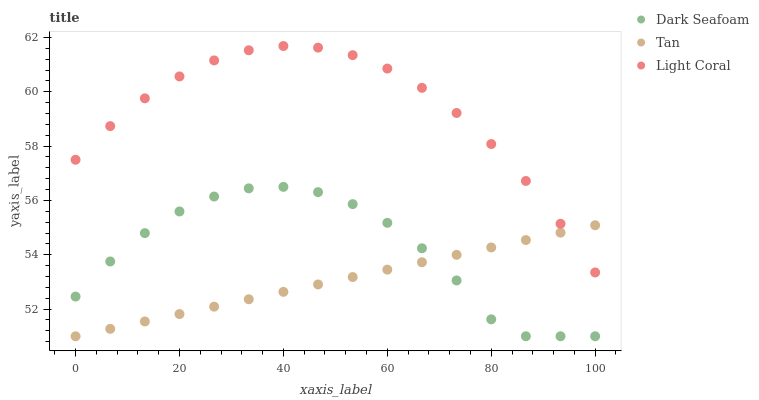Does Tan have the minimum area under the curve?
Answer yes or no. Yes. Does Light Coral have the maximum area under the curve?
Answer yes or no. Yes. Does Dark Seafoam have the minimum area under the curve?
Answer yes or no. No. Does Dark Seafoam have the maximum area under the curve?
Answer yes or no. No. Is Tan the smoothest?
Answer yes or no. Yes. Is Dark Seafoam the roughest?
Answer yes or no. Yes. Is Dark Seafoam the smoothest?
Answer yes or no. No. Is Tan the roughest?
Answer yes or no. No. Does Dark Seafoam have the lowest value?
Answer yes or no. Yes. Does Light Coral have the highest value?
Answer yes or no. Yes. Does Dark Seafoam have the highest value?
Answer yes or no. No. Is Dark Seafoam less than Light Coral?
Answer yes or no. Yes. Is Light Coral greater than Dark Seafoam?
Answer yes or no. Yes. Does Light Coral intersect Tan?
Answer yes or no. Yes. Is Light Coral less than Tan?
Answer yes or no. No. Is Light Coral greater than Tan?
Answer yes or no. No. Does Dark Seafoam intersect Light Coral?
Answer yes or no. No. 